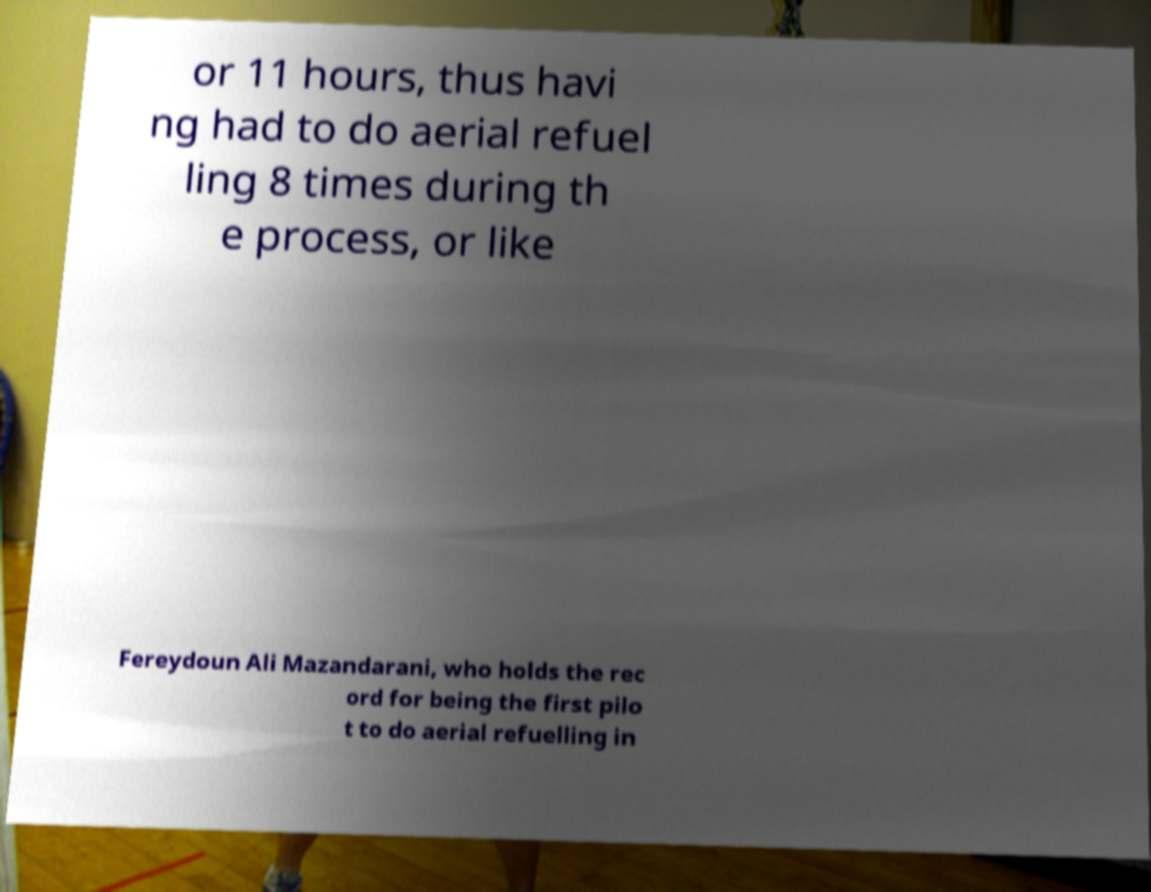For documentation purposes, I need the text within this image transcribed. Could you provide that? or 11 hours, thus havi ng had to do aerial refuel ling 8 times during th e process, or like Fereydoun Ali Mazandarani, who holds the rec ord for being the first pilo t to do aerial refuelling in 